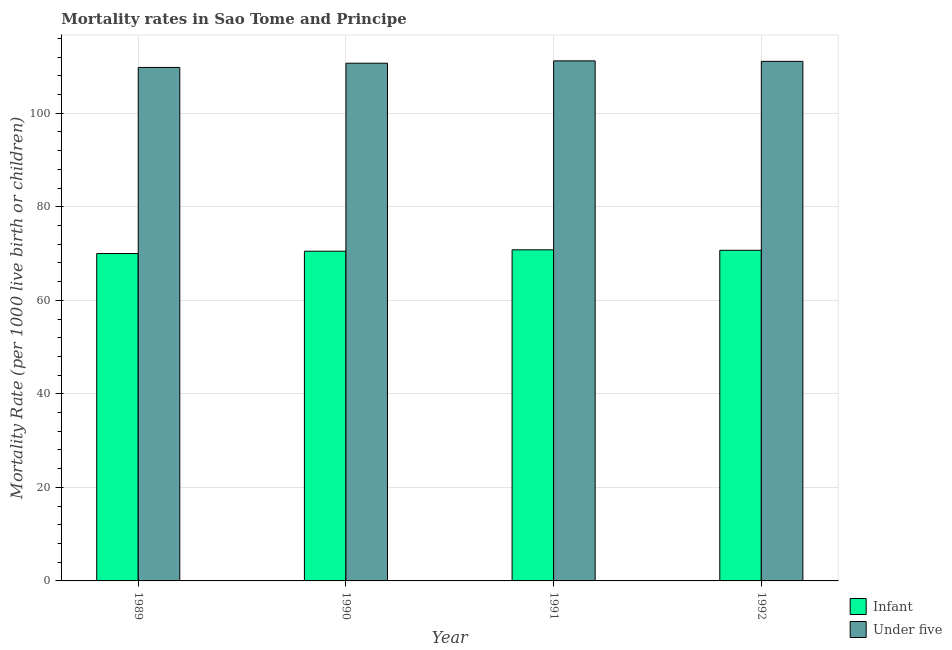How many groups of bars are there?
Your answer should be compact. 4. How many bars are there on the 1st tick from the left?
Give a very brief answer. 2. How many bars are there on the 3rd tick from the right?
Ensure brevity in your answer.  2. What is the infant mortality rate in 1989?
Make the answer very short. 70. Across all years, what is the maximum under-5 mortality rate?
Give a very brief answer. 111.2. Across all years, what is the minimum infant mortality rate?
Your answer should be very brief. 70. In which year was the under-5 mortality rate maximum?
Keep it short and to the point. 1991. What is the total infant mortality rate in the graph?
Your response must be concise. 282. What is the difference between the infant mortality rate in 1989 and that in 1992?
Keep it short and to the point. -0.7. What is the difference between the infant mortality rate in 1992 and the under-5 mortality rate in 1989?
Ensure brevity in your answer.  0.7. What is the average infant mortality rate per year?
Your response must be concise. 70.5. What is the ratio of the infant mortality rate in 1989 to that in 1991?
Make the answer very short. 0.99. Is the difference between the under-5 mortality rate in 1991 and 1992 greater than the difference between the infant mortality rate in 1991 and 1992?
Provide a short and direct response. No. What is the difference between the highest and the second highest under-5 mortality rate?
Keep it short and to the point. 0.1. What is the difference between the highest and the lowest under-5 mortality rate?
Offer a terse response. 1.4. In how many years, is the infant mortality rate greater than the average infant mortality rate taken over all years?
Provide a succinct answer. 2. What does the 2nd bar from the left in 1991 represents?
Your answer should be compact. Under five. What does the 1st bar from the right in 1992 represents?
Your answer should be very brief. Under five. How many years are there in the graph?
Your answer should be compact. 4. Does the graph contain any zero values?
Provide a succinct answer. No. Does the graph contain grids?
Provide a succinct answer. Yes. Where does the legend appear in the graph?
Keep it short and to the point. Bottom right. What is the title of the graph?
Ensure brevity in your answer.  Mortality rates in Sao Tome and Principe. Does "Merchandise exports" appear as one of the legend labels in the graph?
Provide a short and direct response. No. What is the label or title of the X-axis?
Your answer should be compact. Year. What is the label or title of the Y-axis?
Provide a succinct answer. Mortality Rate (per 1000 live birth or children). What is the Mortality Rate (per 1000 live birth or children) in Under five in 1989?
Offer a terse response. 109.8. What is the Mortality Rate (per 1000 live birth or children) in Infant in 1990?
Keep it short and to the point. 70.5. What is the Mortality Rate (per 1000 live birth or children) in Under five in 1990?
Ensure brevity in your answer.  110.7. What is the Mortality Rate (per 1000 live birth or children) of Infant in 1991?
Offer a very short reply. 70.8. What is the Mortality Rate (per 1000 live birth or children) of Under five in 1991?
Ensure brevity in your answer.  111.2. What is the Mortality Rate (per 1000 live birth or children) of Infant in 1992?
Give a very brief answer. 70.7. What is the Mortality Rate (per 1000 live birth or children) in Under five in 1992?
Ensure brevity in your answer.  111.1. Across all years, what is the maximum Mortality Rate (per 1000 live birth or children) of Infant?
Give a very brief answer. 70.8. Across all years, what is the maximum Mortality Rate (per 1000 live birth or children) in Under five?
Provide a succinct answer. 111.2. Across all years, what is the minimum Mortality Rate (per 1000 live birth or children) in Infant?
Your answer should be very brief. 70. Across all years, what is the minimum Mortality Rate (per 1000 live birth or children) of Under five?
Your answer should be compact. 109.8. What is the total Mortality Rate (per 1000 live birth or children) of Infant in the graph?
Provide a short and direct response. 282. What is the total Mortality Rate (per 1000 live birth or children) in Under five in the graph?
Keep it short and to the point. 442.8. What is the difference between the Mortality Rate (per 1000 live birth or children) in Under five in 1989 and that in 1990?
Make the answer very short. -0.9. What is the difference between the Mortality Rate (per 1000 live birth or children) in Under five in 1989 and that in 1991?
Provide a short and direct response. -1.4. What is the difference between the Mortality Rate (per 1000 live birth or children) of Under five in 1989 and that in 1992?
Provide a succinct answer. -1.3. What is the difference between the Mortality Rate (per 1000 live birth or children) of Infant in 1990 and that in 1991?
Give a very brief answer. -0.3. What is the difference between the Mortality Rate (per 1000 live birth or children) of Under five in 1990 and that in 1991?
Give a very brief answer. -0.5. What is the difference between the Mortality Rate (per 1000 live birth or children) of Infant in 1990 and that in 1992?
Your answer should be compact. -0.2. What is the difference between the Mortality Rate (per 1000 live birth or children) in Under five in 1990 and that in 1992?
Your answer should be very brief. -0.4. What is the difference between the Mortality Rate (per 1000 live birth or children) in Under five in 1991 and that in 1992?
Keep it short and to the point. 0.1. What is the difference between the Mortality Rate (per 1000 live birth or children) in Infant in 1989 and the Mortality Rate (per 1000 live birth or children) in Under five in 1990?
Offer a very short reply. -40.7. What is the difference between the Mortality Rate (per 1000 live birth or children) of Infant in 1989 and the Mortality Rate (per 1000 live birth or children) of Under five in 1991?
Offer a terse response. -41.2. What is the difference between the Mortality Rate (per 1000 live birth or children) of Infant in 1989 and the Mortality Rate (per 1000 live birth or children) of Under five in 1992?
Provide a short and direct response. -41.1. What is the difference between the Mortality Rate (per 1000 live birth or children) in Infant in 1990 and the Mortality Rate (per 1000 live birth or children) in Under five in 1991?
Keep it short and to the point. -40.7. What is the difference between the Mortality Rate (per 1000 live birth or children) of Infant in 1990 and the Mortality Rate (per 1000 live birth or children) of Under five in 1992?
Give a very brief answer. -40.6. What is the difference between the Mortality Rate (per 1000 live birth or children) in Infant in 1991 and the Mortality Rate (per 1000 live birth or children) in Under five in 1992?
Your answer should be compact. -40.3. What is the average Mortality Rate (per 1000 live birth or children) of Infant per year?
Keep it short and to the point. 70.5. What is the average Mortality Rate (per 1000 live birth or children) in Under five per year?
Your answer should be compact. 110.7. In the year 1989, what is the difference between the Mortality Rate (per 1000 live birth or children) in Infant and Mortality Rate (per 1000 live birth or children) in Under five?
Provide a succinct answer. -39.8. In the year 1990, what is the difference between the Mortality Rate (per 1000 live birth or children) in Infant and Mortality Rate (per 1000 live birth or children) in Under five?
Offer a terse response. -40.2. In the year 1991, what is the difference between the Mortality Rate (per 1000 live birth or children) of Infant and Mortality Rate (per 1000 live birth or children) of Under five?
Provide a succinct answer. -40.4. In the year 1992, what is the difference between the Mortality Rate (per 1000 live birth or children) of Infant and Mortality Rate (per 1000 live birth or children) of Under five?
Offer a terse response. -40.4. What is the ratio of the Mortality Rate (per 1000 live birth or children) of Under five in 1989 to that in 1990?
Give a very brief answer. 0.99. What is the ratio of the Mortality Rate (per 1000 live birth or children) in Infant in 1989 to that in 1991?
Offer a very short reply. 0.99. What is the ratio of the Mortality Rate (per 1000 live birth or children) in Under five in 1989 to that in 1991?
Give a very brief answer. 0.99. What is the ratio of the Mortality Rate (per 1000 live birth or children) in Infant in 1989 to that in 1992?
Your answer should be compact. 0.99. What is the ratio of the Mortality Rate (per 1000 live birth or children) of Under five in 1989 to that in 1992?
Offer a very short reply. 0.99. What is the ratio of the Mortality Rate (per 1000 live birth or children) in Infant in 1990 to that in 1991?
Provide a short and direct response. 1. What is the ratio of the Mortality Rate (per 1000 live birth or children) in Infant in 1990 to that in 1992?
Offer a very short reply. 1. What is the ratio of the Mortality Rate (per 1000 live birth or children) in Under five in 1990 to that in 1992?
Give a very brief answer. 1. What is the ratio of the Mortality Rate (per 1000 live birth or children) of Under five in 1991 to that in 1992?
Ensure brevity in your answer.  1. What is the difference between the highest and the second highest Mortality Rate (per 1000 live birth or children) in Infant?
Your answer should be compact. 0.1. What is the difference between the highest and the second highest Mortality Rate (per 1000 live birth or children) of Under five?
Make the answer very short. 0.1. 